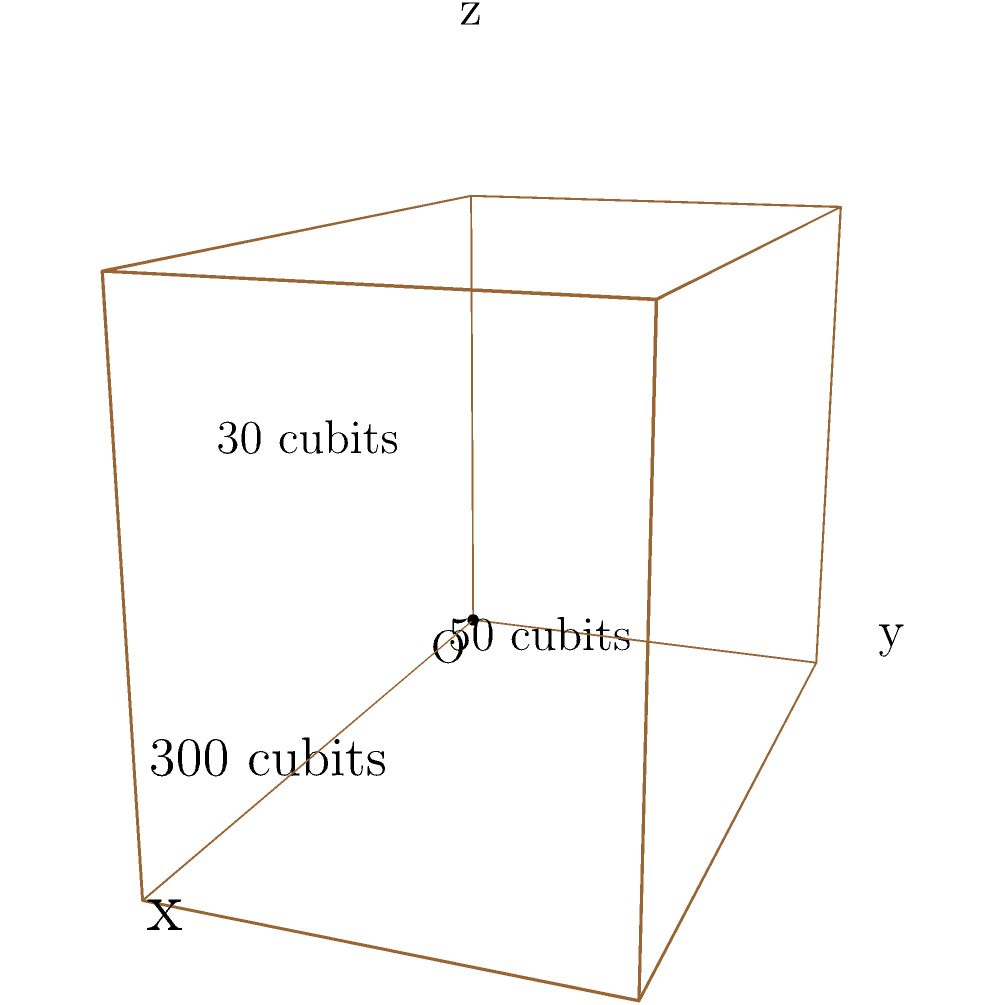In the 3D coordinate system shown, Noah's Ark is represented as a rectangular prism. Given that the dimensions of the Ark are 300 cubits long, 50 cubits wide, and 30 cubits high, what would be the coordinates of the point that represents the top front right corner of the Ark? To find the coordinates of the top front right corner of Noah's Ark, we need to consider its dimensions in relation to the 3D coordinate system:

1. The origin (O) is at the bottom left rear corner of the Ark.
2. The x-axis represents the length (300 cubits).
3. The y-axis represents the width (50 cubits).
4. The z-axis represents the height (30 cubits).

The top front right corner will have:
- x-coordinate: The full length of the Ark (300 cubits)
- y-coordinate: The full width of the Ark (50 cubits)
- z-coordinate: The full height of the Ark (30 cubits)

Therefore, the coordinates of the top front right corner will be (300, 50, 30) in this 3D coordinate system.
Answer: (300, 50, 30) 